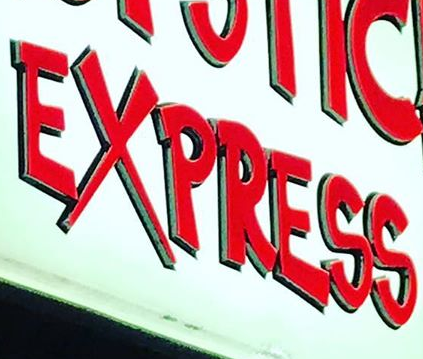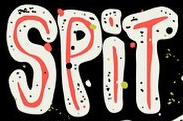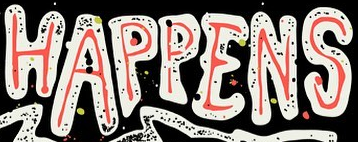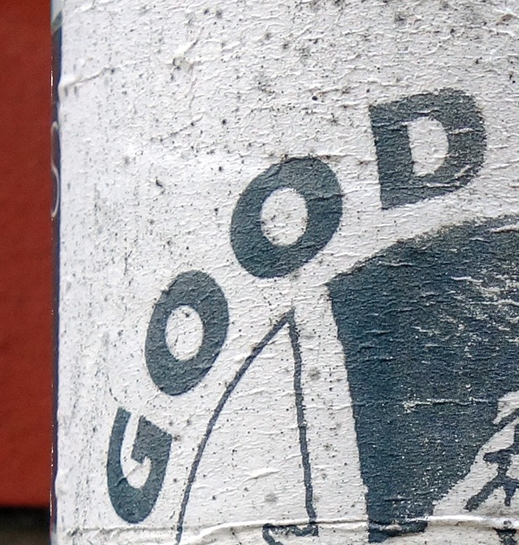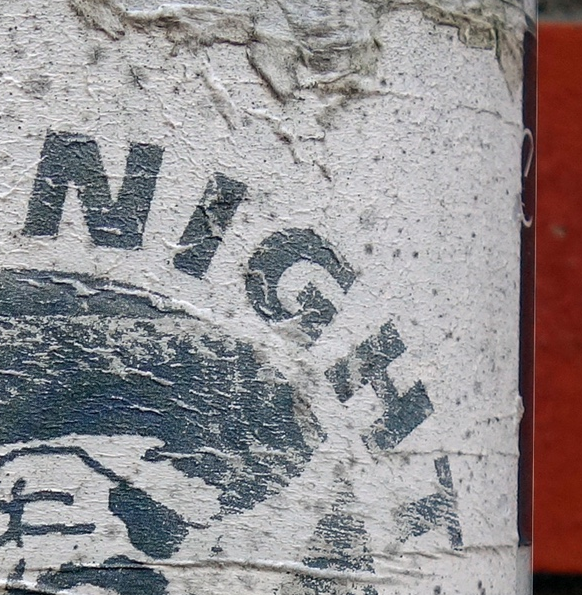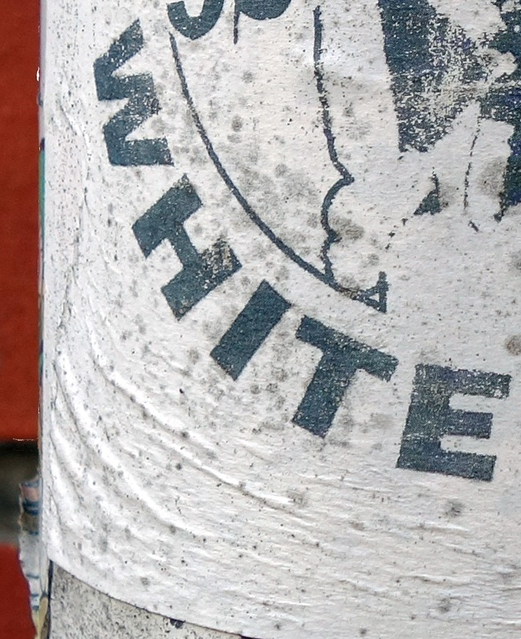Read the text content from these images in order, separated by a semicolon. EXPRESS; SPiT; HAPPENS; GOOD; NIGHT; WHITE 